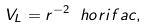Convert formula to latex. <formula><loc_0><loc_0><loc_500><loc_500>V _ { L } = r ^ { - 2 } \ h o r i f a c ,</formula> 